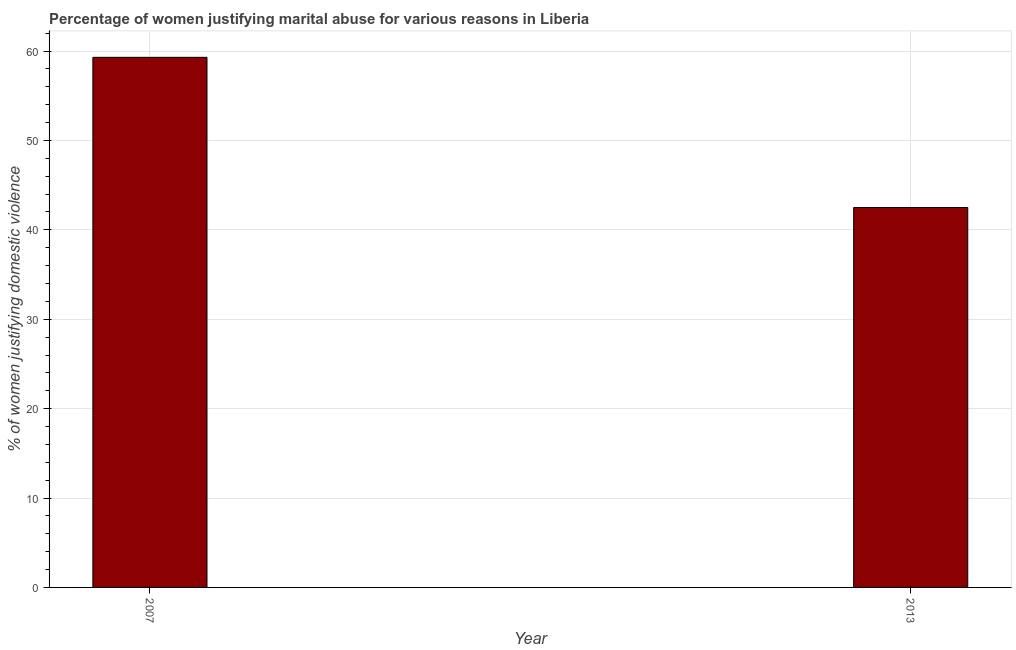What is the title of the graph?
Your answer should be compact. Percentage of women justifying marital abuse for various reasons in Liberia. What is the label or title of the Y-axis?
Provide a succinct answer. % of women justifying domestic violence. What is the percentage of women justifying marital abuse in 2007?
Provide a succinct answer. 59.3. Across all years, what is the maximum percentage of women justifying marital abuse?
Offer a very short reply. 59.3. Across all years, what is the minimum percentage of women justifying marital abuse?
Ensure brevity in your answer.  42.5. In which year was the percentage of women justifying marital abuse maximum?
Provide a succinct answer. 2007. What is the sum of the percentage of women justifying marital abuse?
Your response must be concise. 101.8. What is the difference between the percentage of women justifying marital abuse in 2007 and 2013?
Make the answer very short. 16.8. What is the average percentage of women justifying marital abuse per year?
Your answer should be very brief. 50.9. What is the median percentage of women justifying marital abuse?
Your answer should be compact. 50.9. What is the ratio of the percentage of women justifying marital abuse in 2007 to that in 2013?
Provide a short and direct response. 1.4. Is the percentage of women justifying marital abuse in 2007 less than that in 2013?
Keep it short and to the point. No. Are all the bars in the graph horizontal?
Your answer should be compact. No. How many years are there in the graph?
Ensure brevity in your answer.  2. What is the % of women justifying domestic violence of 2007?
Make the answer very short. 59.3. What is the % of women justifying domestic violence of 2013?
Ensure brevity in your answer.  42.5. What is the difference between the % of women justifying domestic violence in 2007 and 2013?
Offer a very short reply. 16.8. What is the ratio of the % of women justifying domestic violence in 2007 to that in 2013?
Provide a short and direct response. 1.4. 